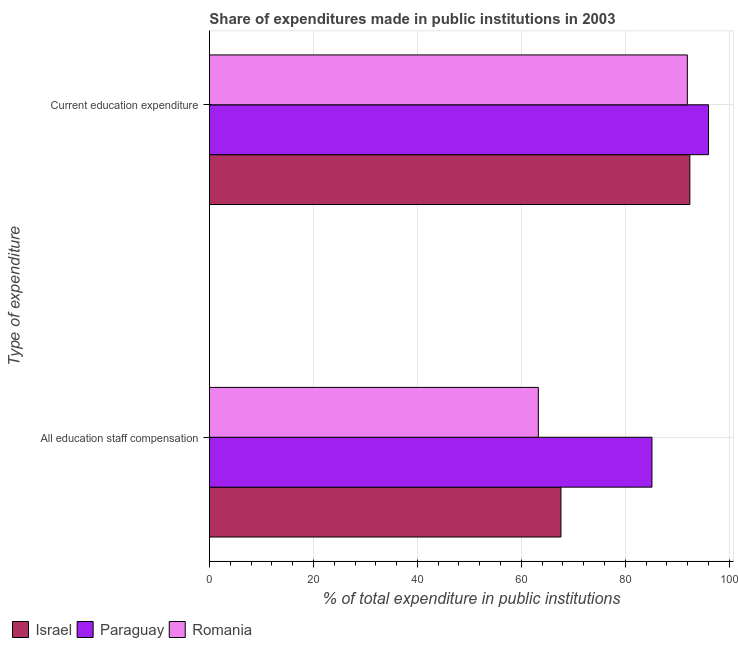How many different coloured bars are there?
Offer a very short reply. 3. Are the number of bars on each tick of the Y-axis equal?
Give a very brief answer. Yes. How many bars are there on the 2nd tick from the top?
Your answer should be compact. 3. How many bars are there on the 1st tick from the bottom?
Your answer should be compact. 3. What is the label of the 1st group of bars from the top?
Keep it short and to the point. Current education expenditure. What is the expenditure in staff compensation in Paraguay?
Provide a short and direct response. 85.12. Across all countries, what is the maximum expenditure in education?
Give a very brief answer. 96. Across all countries, what is the minimum expenditure in staff compensation?
Your answer should be very brief. 63.27. In which country was the expenditure in education maximum?
Your response must be concise. Paraguay. In which country was the expenditure in education minimum?
Your answer should be very brief. Romania. What is the total expenditure in education in the graph?
Provide a short and direct response. 280.33. What is the difference between the expenditure in staff compensation in Romania and that in Paraguay?
Offer a very short reply. -21.85. What is the difference between the expenditure in staff compensation in Israel and the expenditure in education in Romania?
Your answer should be compact. -24.32. What is the average expenditure in education per country?
Provide a succinct answer. 93.44. What is the difference between the expenditure in staff compensation and expenditure in education in Israel?
Your answer should be compact. -24.8. In how many countries, is the expenditure in staff compensation greater than 20 %?
Your answer should be very brief. 3. What is the ratio of the expenditure in education in Romania to that in Israel?
Ensure brevity in your answer.  0.99. Is the expenditure in staff compensation in Israel less than that in Paraguay?
Make the answer very short. Yes. In how many countries, is the expenditure in staff compensation greater than the average expenditure in staff compensation taken over all countries?
Provide a succinct answer. 1. What does the 2nd bar from the top in All education staff compensation represents?
Offer a very short reply. Paraguay. What does the 1st bar from the bottom in Current education expenditure represents?
Provide a short and direct response. Israel. How many bars are there?
Keep it short and to the point. 6. How many countries are there in the graph?
Offer a terse response. 3. What is the difference between two consecutive major ticks on the X-axis?
Offer a very short reply. 20. Are the values on the major ticks of X-axis written in scientific E-notation?
Your answer should be very brief. No. Does the graph contain grids?
Your answer should be compact. Yes. Where does the legend appear in the graph?
Provide a succinct answer. Bottom left. How many legend labels are there?
Keep it short and to the point. 3. What is the title of the graph?
Your answer should be very brief. Share of expenditures made in public institutions in 2003. What is the label or title of the X-axis?
Make the answer very short. % of total expenditure in public institutions. What is the label or title of the Y-axis?
Your answer should be compact. Type of expenditure. What is the % of total expenditure in public institutions of Israel in All education staff compensation?
Make the answer very short. 67.61. What is the % of total expenditure in public institutions in Paraguay in All education staff compensation?
Offer a terse response. 85.12. What is the % of total expenditure in public institutions of Romania in All education staff compensation?
Offer a terse response. 63.27. What is the % of total expenditure in public institutions in Israel in Current education expenditure?
Your answer should be compact. 92.41. What is the % of total expenditure in public institutions of Paraguay in Current education expenditure?
Offer a terse response. 96. What is the % of total expenditure in public institutions of Romania in Current education expenditure?
Provide a succinct answer. 91.92. Across all Type of expenditure, what is the maximum % of total expenditure in public institutions in Israel?
Offer a terse response. 92.41. Across all Type of expenditure, what is the maximum % of total expenditure in public institutions in Paraguay?
Give a very brief answer. 96. Across all Type of expenditure, what is the maximum % of total expenditure in public institutions in Romania?
Offer a terse response. 91.92. Across all Type of expenditure, what is the minimum % of total expenditure in public institutions of Israel?
Your answer should be compact. 67.61. Across all Type of expenditure, what is the minimum % of total expenditure in public institutions of Paraguay?
Keep it short and to the point. 85.12. Across all Type of expenditure, what is the minimum % of total expenditure in public institutions in Romania?
Give a very brief answer. 63.27. What is the total % of total expenditure in public institutions in Israel in the graph?
Keep it short and to the point. 160.01. What is the total % of total expenditure in public institutions of Paraguay in the graph?
Provide a short and direct response. 181.12. What is the total % of total expenditure in public institutions in Romania in the graph?
Provide a succinct answer. 155.19. What is the difference between the % of total expenditure in public institutions in Israel in All education staff compensation and that in Current education expenditure?
Keep it short and to the point. -24.8. What is the difference between the % of total expenditure in public institutions in Paraguay in All education staff compensation and that in Current education expenditure?
Provide a succinct answer. -10.88. What is the difference between the % of total expenditure in public institutions in Romania in All education staff compensation and that in Current education expenditure?
Provide a short and direct response. -28.66. What is the difference between the % of total expenditure in public institutions in Israel in All education staff compensation and the % of total expenditure in public institutions in Paraguay in Current education expenditure?
Offer a very short reply. -28.39. What is the difference between the % of total expenditure in public institutions in Israel in All education staff compensation and the % of total expenditure in public institutions in Romania in Current education expenditure?
Ensure brevity in your answer.  -24.32. What is the difference between the % of total expenditure in public institutions of Paraguay in All education staff compensation and the % of total expenditure in public institutions of Romania in Current education expenditure?
Give a very brief answer. -6.8. What is the average % of total expenditure in public institutions of Israel per Type of expenditure?
Give a very brief answer. 80.01. What is the average % of total expenditure in public institutions of Paraguay per Type of expenditure?
Your response must be concise. 90.56. What is the average % of total expenditure in public institutions in Romania per Type of expenditure?
Give a very brief answer. 77.59. What is the difference between the % of total expenditure in public institutions in Israel and % of total expenditure in public institutions in Paraguay in All education staff compensation?
Offer a terse response. -17.51. What is the difference between the % of total expenditure in public institutions of Israel and % of total expenditure in public institutions of Romania in All education staff compensation?
Provide a short and direct response. 4.34. What is the difference between the % of total expenditure in public institutions in Paraguay and % of total expenditure in public institutions in Romania in All education staff compensation?
Ensure brevity in your answer.  21.85. What is the difference between the % of total expenditure in public institutions in Israel and % of total expenditure in public institutions in Paraguay in Current education expenditure?
Your response must be concise. -3.59. What is the difference between the % of total expenditure in public institutions in Israel and % of total expenditure in public institutions in Romania in Current education expenditure?
Your answer should be very brief. 0.48. What is the difference between the % of total expenditure in public institutions of Paraguay and % of total expenditure in public institutions of Romania in Current education expenditure?
Your answer should be compact. 4.08. What is the ratio of the % of total expenditure in public institutions in Israel in All education staff compensation to that in Current education expenditure?
Keep it short and to the point. 0.73. What is the ratio of the % of total expenditure in public institutions of Paraguay in All education staff compensation to that in Current education expenditure?
Ensure brevity in your answer.  0.89. What is the ratio of the % of total expenditure in public institutions of Romania in All education staff compensation to that in Current education expenditure?
Provide a short and direct response. 0.69. What is the difference between the highest and the second highest % of total expenditure in public institutions of Israel?
Your response must be concise. 24.8. What is the difference between the highest and the second highest % of total expenditure in public institutions of Paraguay?
Provide a short and direct response. 10.88. What is the difference between the highest and the second highest % of total expenditure in public institutions in Romania?
Offer a terse response. 28.66. What is the difference between the highest and the lowest % of total expenditure in public institutions in Israel?
Your response must be concise. 24.8. What is the difference between the highest and the lowest % of total expenditure in public institutions in Paraguay?
Keep it short and to the point. 10.88. What is the difference between the highest and the lowest % of total expenditure in public institutions in Romania?
Provide a short and direct response. 28.66. 